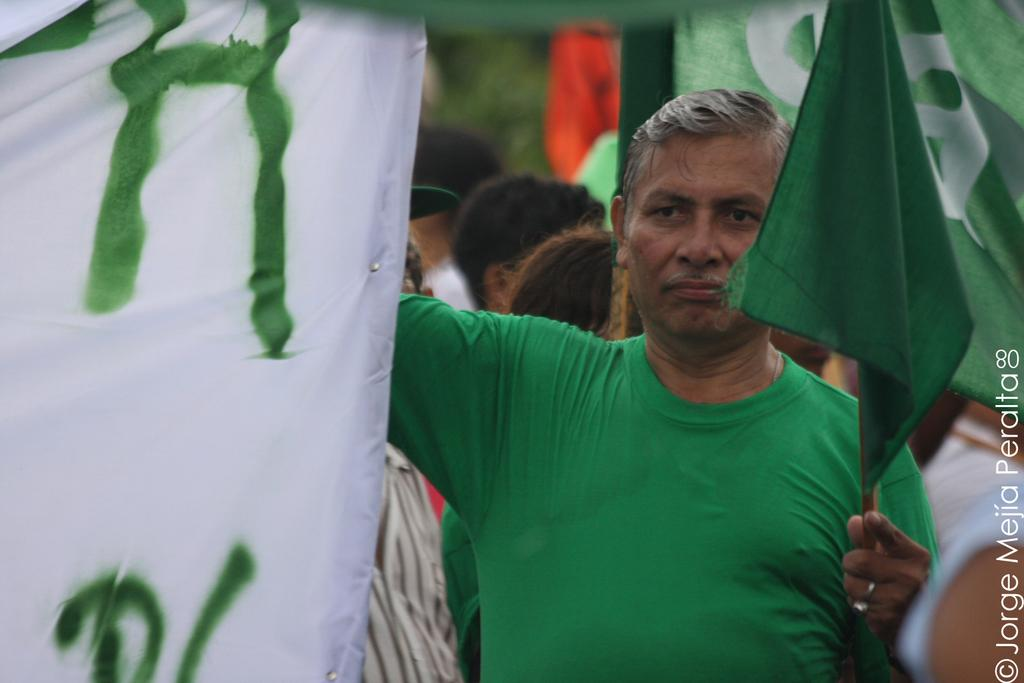What is the person in the image wearing? The person is wearing a green t-shirt in the image. What is the person holding in the image? The person is holding a green color flag in the image. How many people are present in the image? There are many people in the image. What objects are present in the image besides the people? There are flags and a logo in the image. Where is the zebra located in the image? There is no zebra present in the image. What type of mailbox can be seen in the image? There is no mailbox present in the image. 